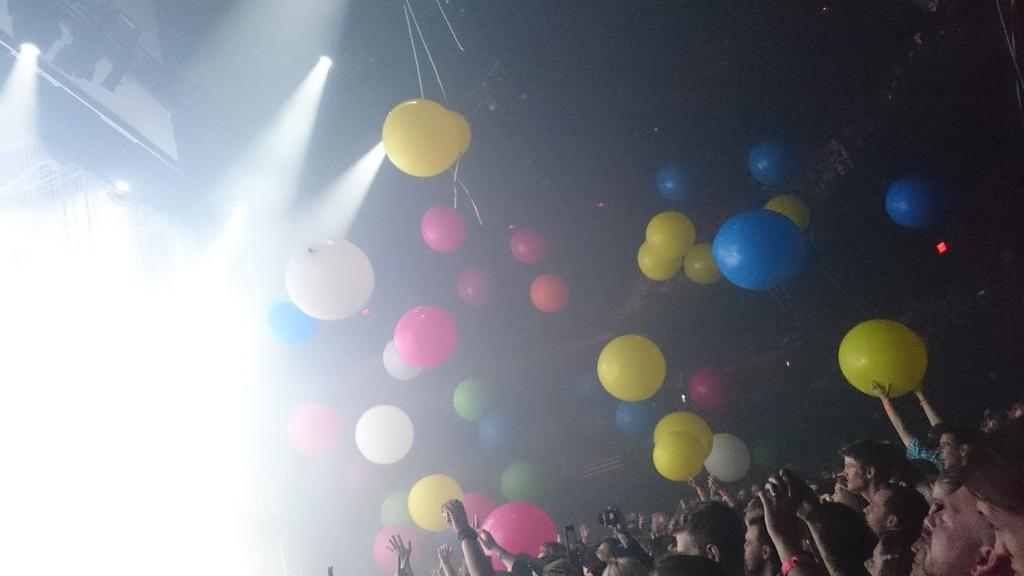How would you summarize this image in a sentence or two? In this picture I can see few people at the bottom, there are balloons in the middle. On the left side I can see the lights. 